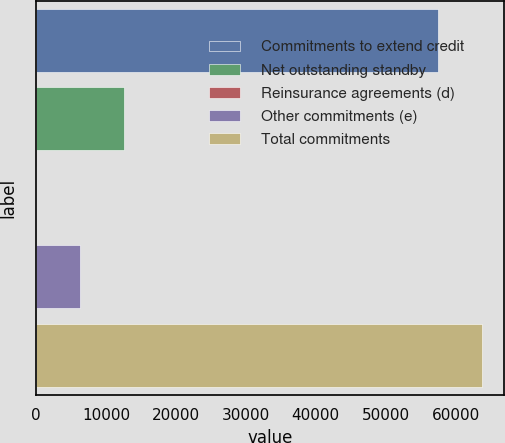Convert chart to OTSL. <chart><loc_0><loc_0><loc_500><loc_500><bar_chart><fcel>Commitments to extend credit<fcel>Net outstanding standby<fcel>Reinsurance agreements (d)<fcel>Other commitments (e)<fcel>Total commitments<nl><fcel>57413<fcel>12573<fcel>4<fcel>6288.5<fcel>63697.5<nl></chart> 